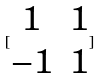<formula> <loc_0><loc_0><loc_500><loc_500>[ \begin{matrix} 1 & 1 \\ - 1 & 1 \end{matrix} ]</formula> 